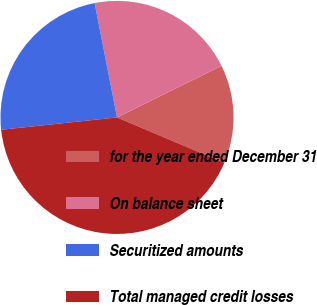Convert chart. <chart><loc_0><loc_0><loc_500><loc_500><pie_chart><fcel>for the year ended December 31<fcel>On balance sheet<fcel>Securitized amounts<fcel>Total managed credit losses<nl><fcel>13.67%<fcel>20.78%<fcel>23.61%<fcel>41.94%<nl></chart> 